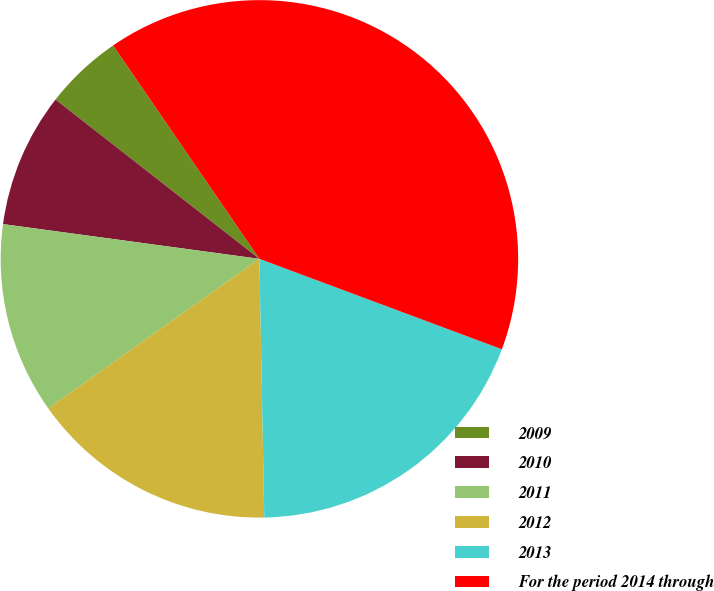<chart> <loc_0><loc_0><loc_500><loc_500><pie_chart><fcel>2009<fcel>2010<fcel>2011<fcel>2012<fcel>2013<fcel>For the period 2014 through<nl><fcel>4.88%<fcel>8.41%<fcel>11.95%<fcel>15.49%<fcel>19.02%<fcel>40.24%<nl></chart> 